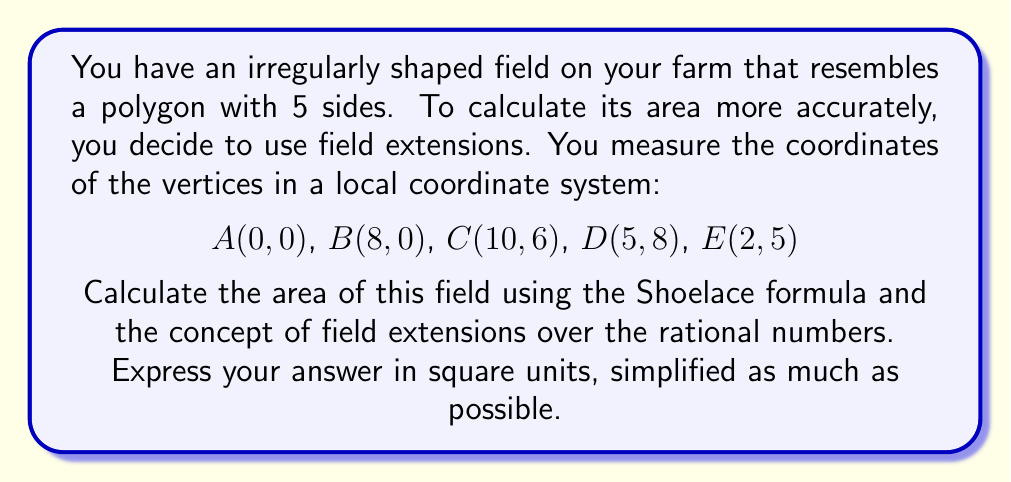Solve this math problem. Let's approach this step-by-step:

1) The Shoelace formula for the area of a polygon with vertices $(x_1, y_1), (x_2, y_2), ..., (x_n, y_n)$ is:

   $$A = \frac{1}{2}|(x_1y_2 + x_2y_3 + ... + x_ny_1) - (y_1x_2 + y_2x_3 + ... + y_nx_1)|$$

2) Substituting our coordinates:

   $$A = \frac{1}{2}|(0\cdot0 + 8\cdot6 + 10\cdot8 + 5\cdot5 + 2\cdot0) - (0\cdot8 + 0\cdot10 + 6\cdot5 + 8\cdot2 + 5\cdot0)|$$

3) Simplifying:

   $$A = \frac{1}{2}|(48 + 80 + 25) - (30 + 16)|$$
   $$A = \frac{1}{2}|153 - 46|$$
   $$A = \frac{1}{2}(107)$$
   $$A = 53.5$$

4) Now, we need to consider this in terms of field extensions. The coordinates are all integers, which are elements of the rational number field $\mathbb{Q}$. However, our result (53.5) is not in $\mathbb{Q}$.

5) To express this exactly, we need to extend our field to include $\sqrt{2}$. This is because 53.5 can be written as $\frac{107}{2}$, which is in $\mathbb{Q}(\sqrt{2})$ as $\frac{107\sqrt{2}}{2\sqrt{2}}$.

6) Therefore, the exact area in the field extension $\mathbb{Q}(\sqrt{2})$ is $\frac{107}{2}$ square units.
Answer: $\frac{107}{2}$ square units in $\mathbb{Q}(\sqrt{2})$ 